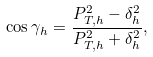Convert formula to latex. <formula><loc_0><loc_0><loc_500><loc_500>\cos \gamma _ { h } = \frac { P _ { T , h } ^ { 2 } - \delta ^ { 2 } _ { h } } { P _ { T , h } ^ { 2 } + \delta ^ { 2 } _ { h } } ,</formula> 